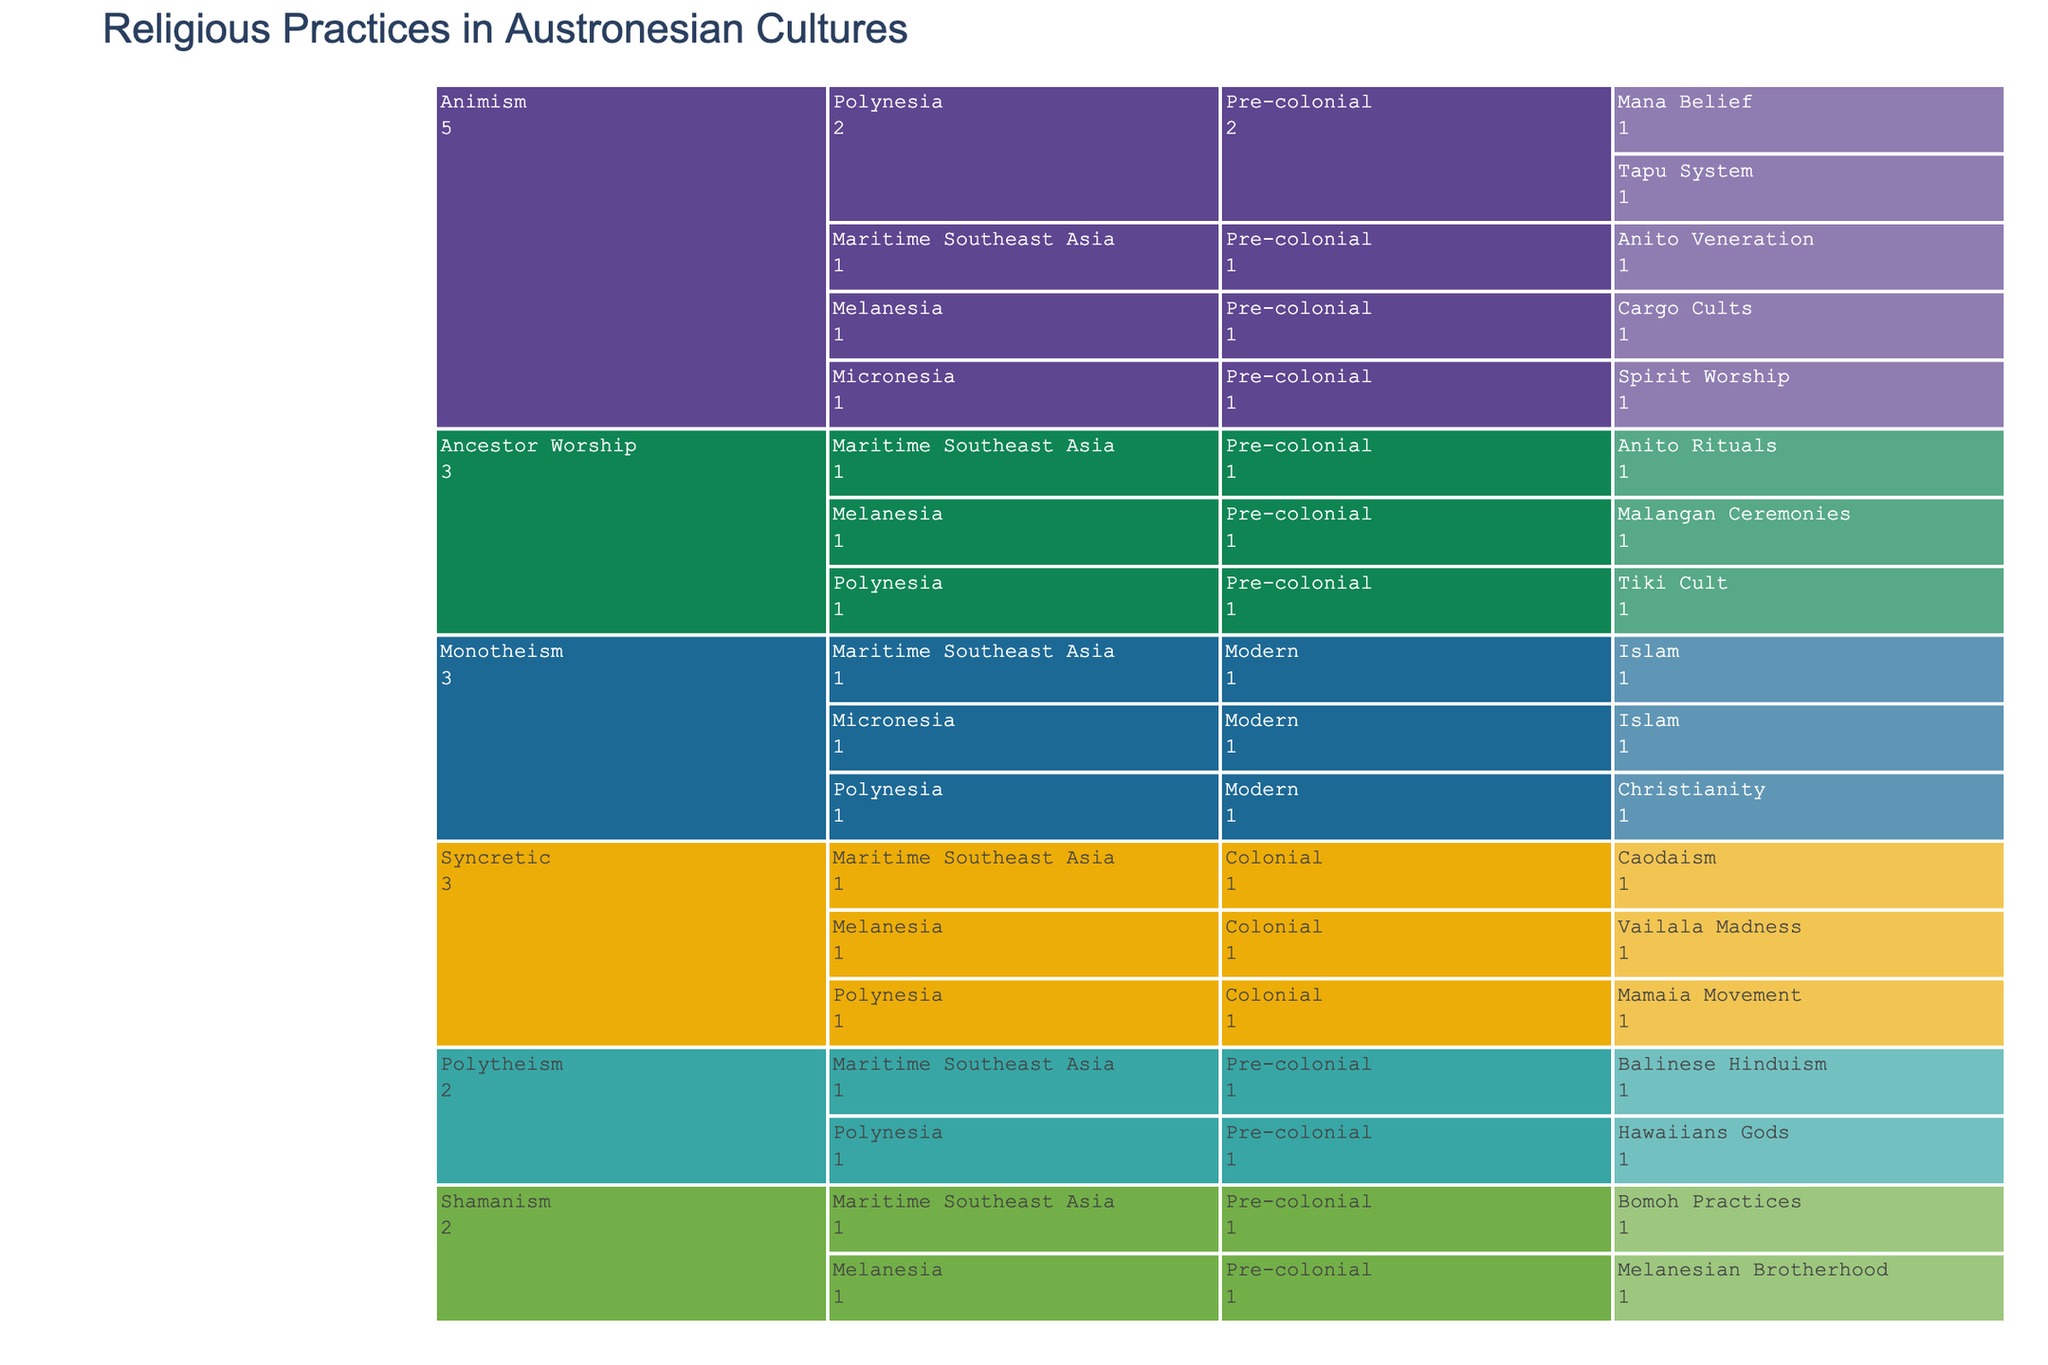Which regions have practices classified under Animism? Look for the regions listed under the Animism category. The regions are Polynesia, Melanesia, Micronesia, and Maritime Southeast Asia.
Answer: Polynesia, Melanesia, Micronesia, Maritime Southeast Asia Name a practice under Syncretic in the Colonial period for Melanesia. Navigate to the Syncretic category, then to the Melanesia region under the Colonial period. The practice is Vailala Madness.
Answer: Vailala Madness Which religious types have practices in both the Polynesia and Maritime Southeast Asia regions? Check the different religious types and see which ones have practices categorized under both Polynesia and Maritime Southeast Asia. Ancestor Worship, Animism, Monotheism, Polytheism, and Syncretic show practices in both regions.
Answer: Ancestor Worship, Animism, Monotheism, Polytheism, Syncretic How many practices are listed under the Pre-colonial period? Count the number of practices under each historical period and filter out Pre-colonial. There are 11 practices in the Pre-colonial period.
Answer: 11 Compare the number of practices under Monotheism and Polytheism. Which type has more practices? Count the practices listed under Monotheism (3) and Polytheism (2). Monotheism has more practices.
Answer: Monotheism Which type of religion has the most diversity in practices for the Pre-colonial period? Check for the Pre-colonial period category and see which type has the most distinct practices listed. Animism has the highest diversity with 5 distinct practices.
Answer: Animism Do any regions have practices spanning all three historical periods? Check if there are any regions with practices listed in Pre-colonial, Colonial, and Modern periods. Only Maritime Southeast Asia has practices in all three periods.
Answer: Maritime Southeast Asia What syncretic practices can be found in the Polynesia region? Navigate to the Syncretic category and then to the Polynesia region. The practice is the Mamaia Movement.
Answer: Mamaia Movement Which practice in Micronesia is listed under Monotheism? Look under the Monotheism category in the Micronesia region. The listed practice is Islam.
Answer: Islam 